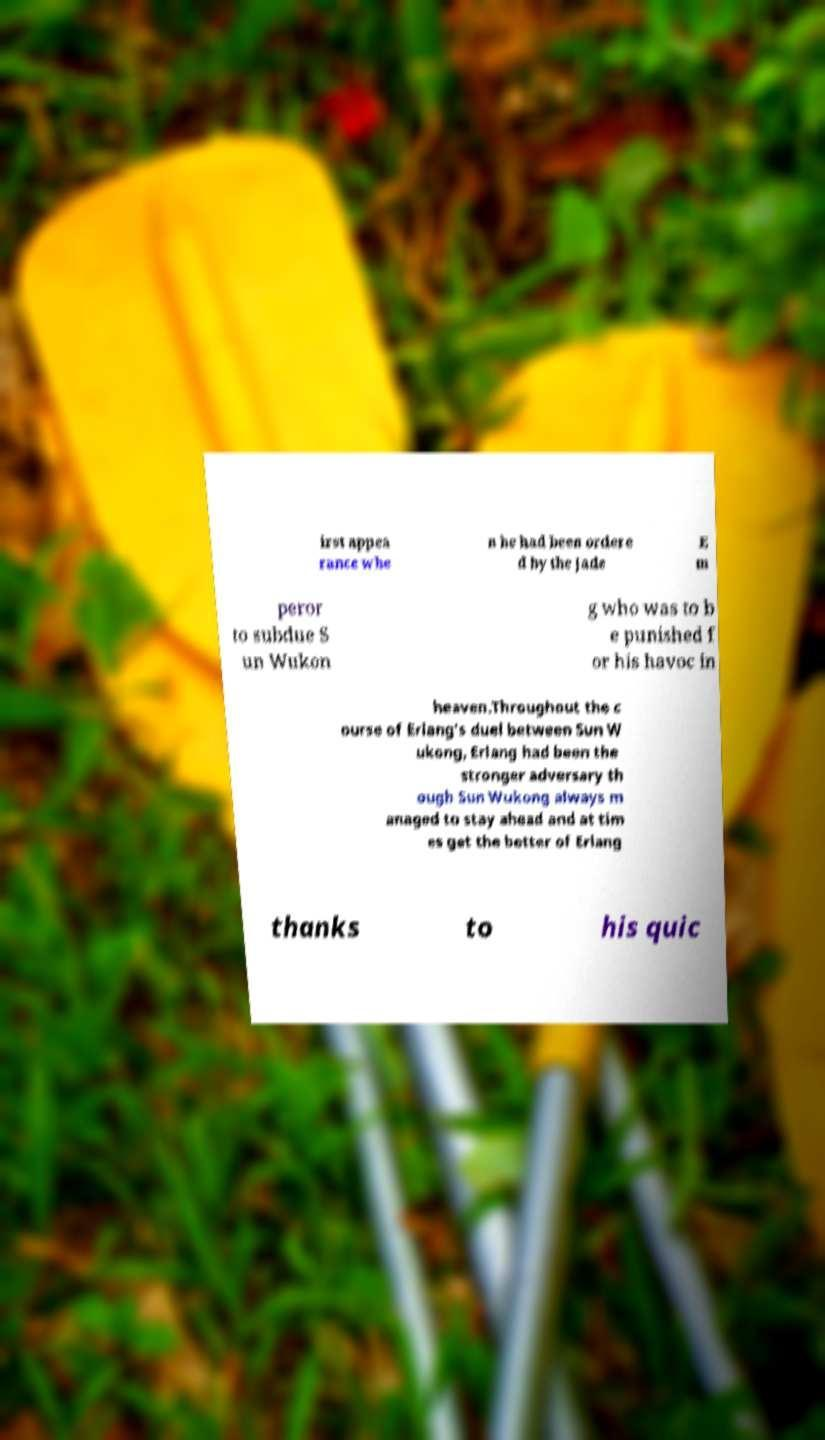What messages or text are displayed in this image? I need them in a readable, typed format. irst appea rance whe n he had been ordere d by the Jade E m peror to subdue S un Wukon g who was to b e punished f or his havoc in heaven.Throughout the c ourse of Erlang's duel between Sun W ukong, Erlang had been the stronger adversary th ough Sun Wukong always m anaged to stay ahead and at tim es get the better of Erlang thanks to his quic 